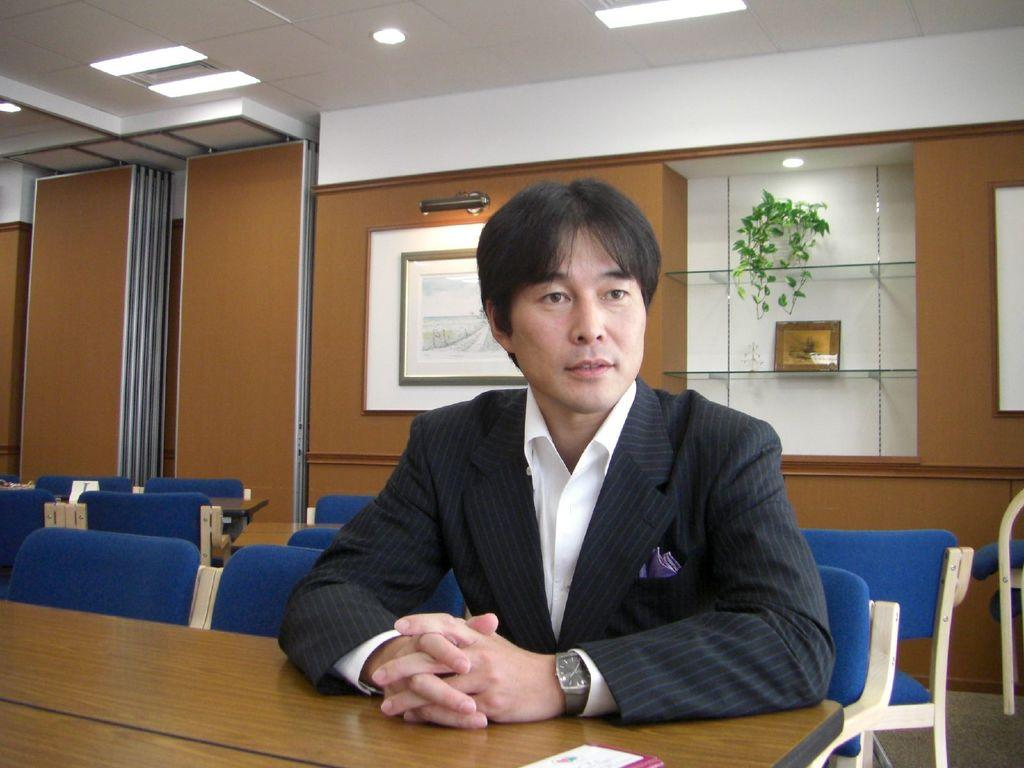What is the main subject of the image? There is a person in the image. What is the person wearing? The person is wearing a black suit. What is the person sitting on? The person is sitting in a blue chair. What is in front of the person? There is a table in front of the person. What is behind the person? There are chairs behind the person. What color are the walls in the image? The walls in the image are brown. How many sticks can be seen in the image? There are no sticks present in the image. What type of coach is standing behind the person in the image? There is no coach present in the image. 